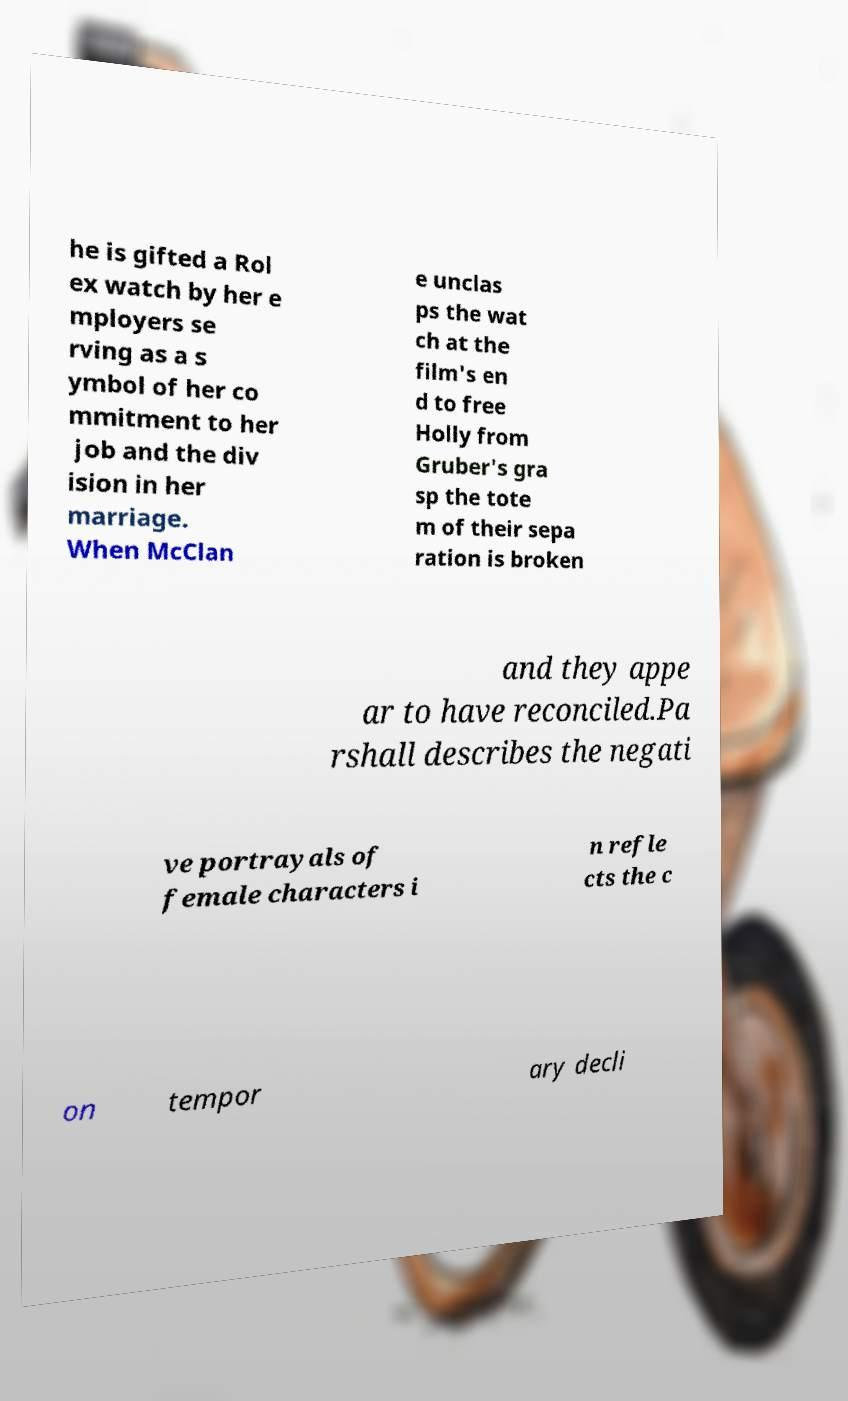Can you accurately transcribe the text from the provided image for me? he is gifted a Rol ex watch by her e mployers se rving as a s ymbol of her co mmitment to her job and the div ision in her marriage. When McClan e unclas ps the wat ch at the film's en d to free Holly from Gruber's gra sp the tote m of their sepa ration is broken and they appe ar to have reconciled.Pa rshall describes the negati ve portrayals of female characters i n refle cts the c on tempor ary decli 